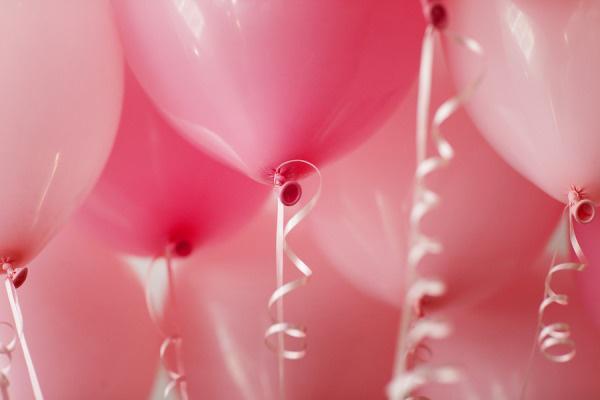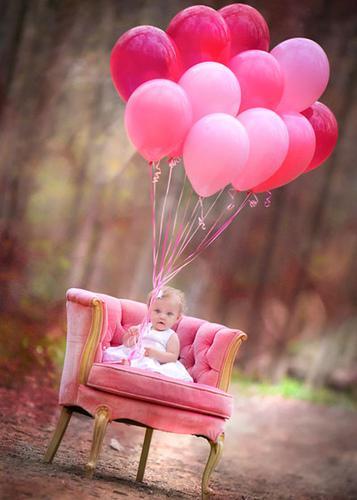The first image is the image on the left, the second image is the image on the right. Given the left and right images, does the statement "In one of the images a seated child is near many balloons." hold true? Answer yes or no. Yes. 